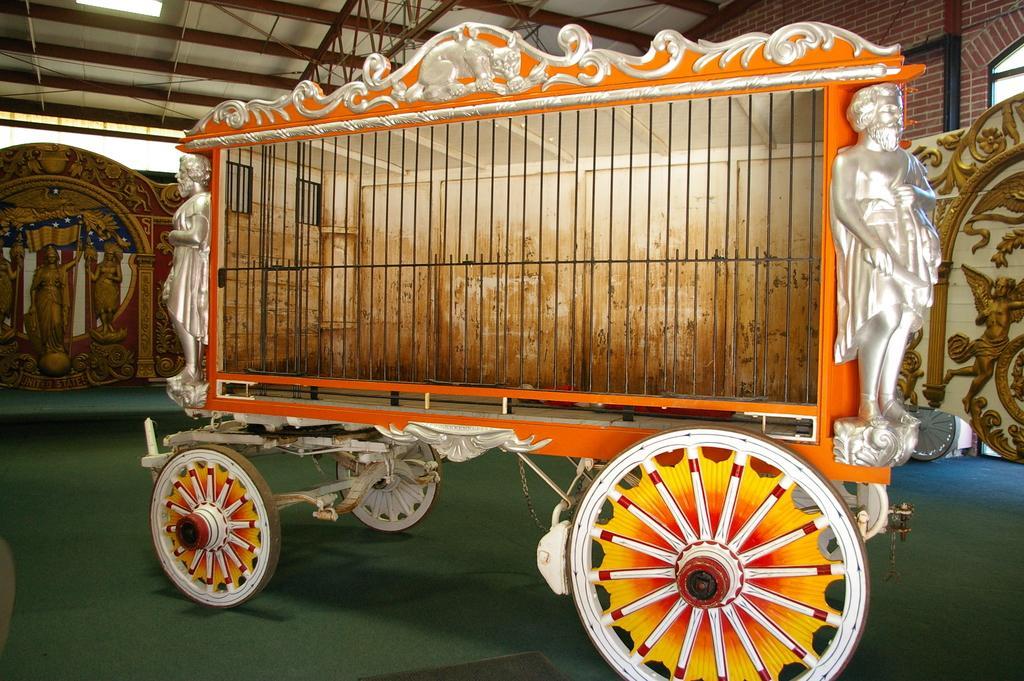Please provide a concise description of this image. In this image we can see a cart, beside that we can see statues, we can see the brick wall, at the top we can see a ceiling with metal frames. And we can see the floor. 